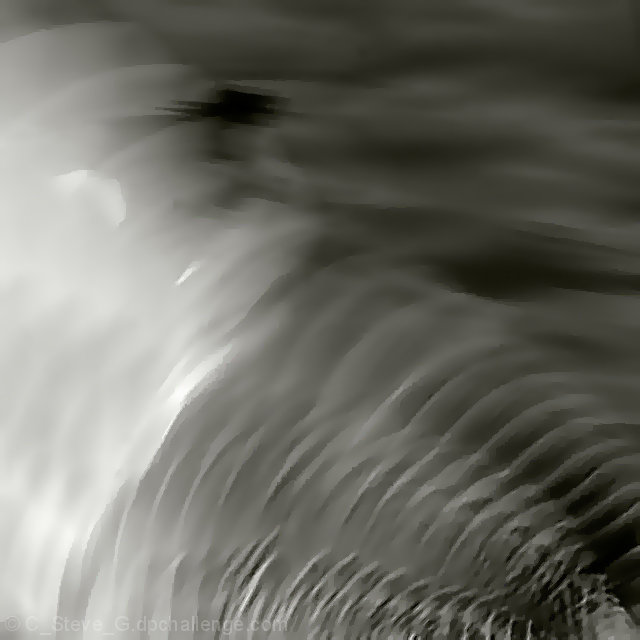Could you describe the texture and patterns observed in this image? The image exhibits a flowing, wave-like texture with rhythmic patterns that resemble ripples on water or undulating sand dunes. The interplay of light and shadow accentuates each curve, giving the composition a dynamic and almost three-dimensional quality. 